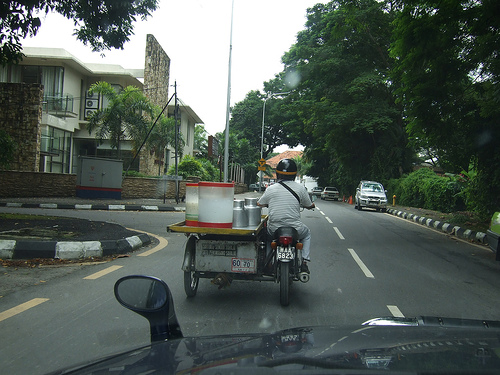<image>
Is there a motorcycle behind the cart? No. The motorcycle is not behind the cart. From this viewpoint, the motorcycle appears to be positioned elsewhere in the scene. Where is the car in relation to the bush? Is it behind the bush? No. The car is not behind the bush. From this viewpoint, the car appears to be positioned elsewhere in the scene. 